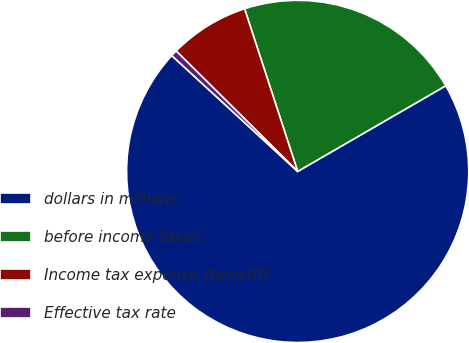<chart> <loc_0><loc_0><loc_500><loc_500><pie_chart><fcel>dollars in millions<fcel>before income taxes<fcel>Income tax expense (benefit)<fcel>Effective tax rate<nl><fcel>70.19%<fcel>21.68%<fcel>7.55%<fcel>0.59%<nl></chart> 